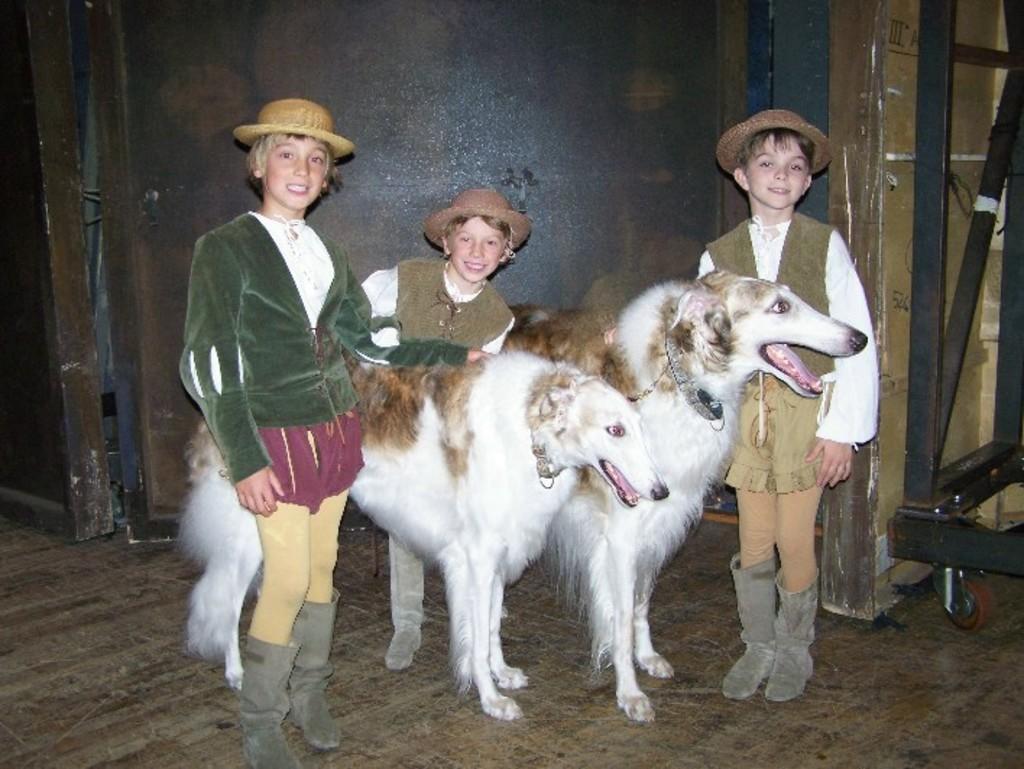Can you describe this image briefly? Inn this image in the foreground there are three boys wearing hats, they are smiling, between them there are two animals visible on the floor , behind them there is the wall, on the right side there is a stand. 